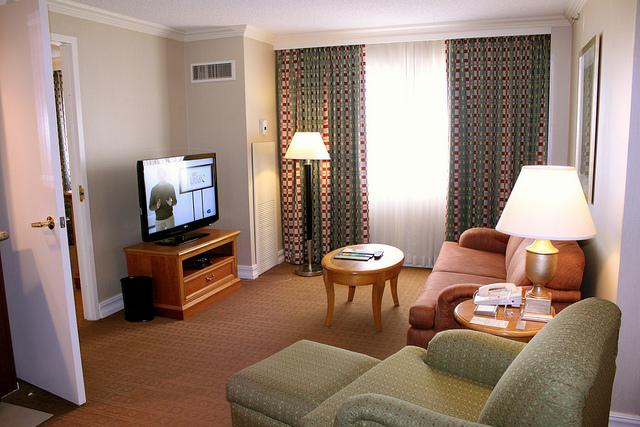What is the appliance in this room used for? Please explain your reasoning. watching. Watching is the intended purpose of a television. it produces pictures to watch. 